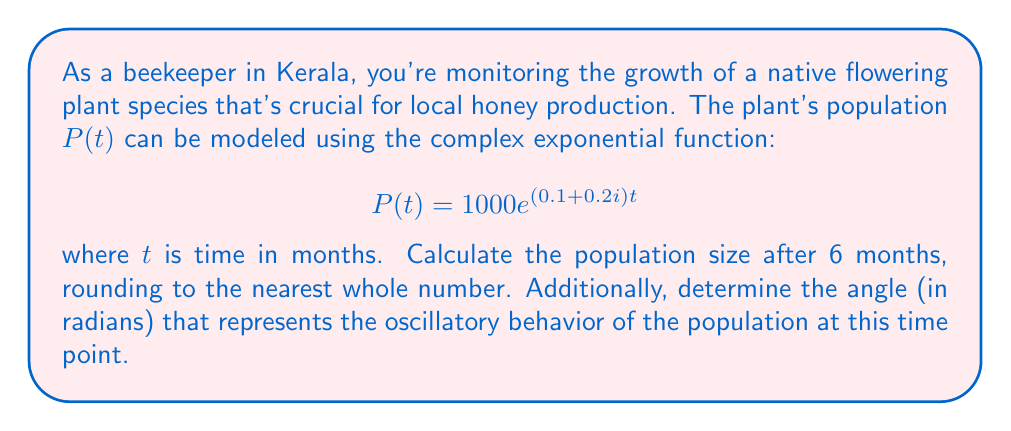Can you solve this math problem? To solve this problem, we need to evaluate the complex exponential function at $t = 6$ and interpret the result.

1) First, let's substitute $t = 6$ into the given function:

   $$P(6) = 1000e^{(0.1 + 0.2i)6} = 1000e^{0.6 + 1.2i}$$

2) We can rewrite this in the form $re^{i\theta}$:
   
   $$1000e^{0.6 + 1.2i} = 1000e^{0.6} \cdot e^{1.2i}$$

3) Calculate $e^{0.6}$:
   
   $$e^{0.6} \approx 1.8221$$

4) Now our expression is:

   $$1000 \cdot 1.8221 \cdot e^{1.2i} \approx 1822.1 \cdot e^{1.2i}$$

5) The magnitude (population size) is 1822.1, which rounds to 1822.

6) The angle $\theta$ that represents the oscillatory behavior is 1.2 radians.

This complex number represents both the population size (magnitude) and its cyclical behavior (angle) after 6 months.
Answer: Population size after 6 months: 1822
Angle representing oscillatory behavior: 1.2 radians 